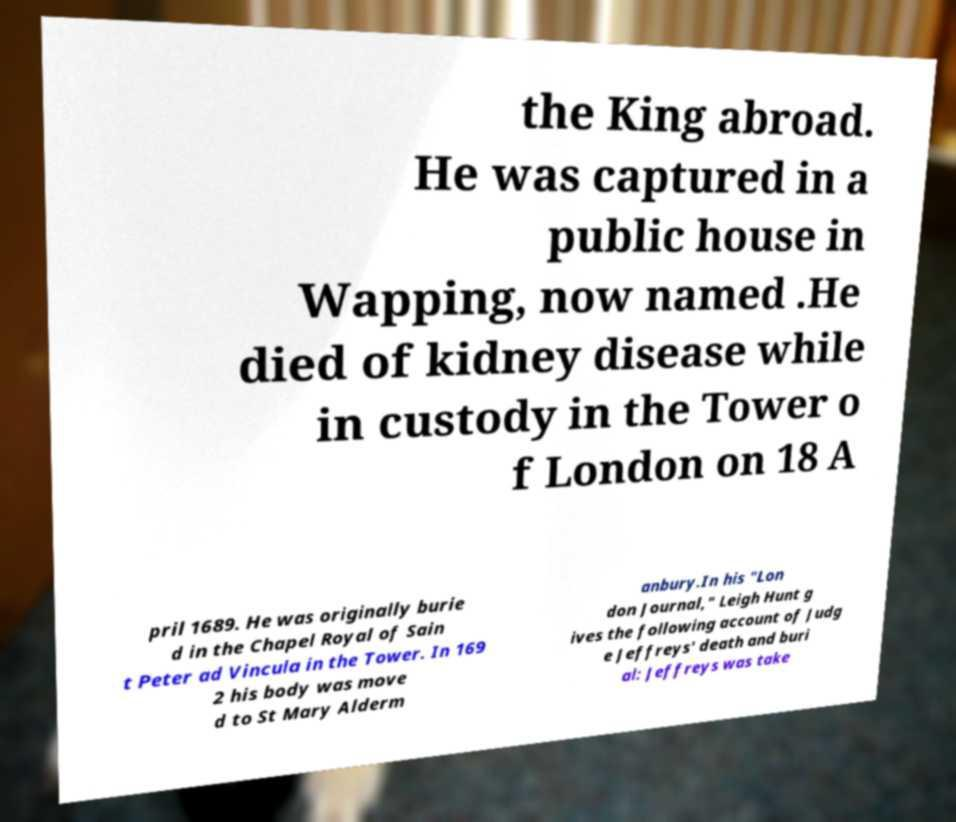Could you extract and type out the text from this image? the King abroad. He was captured in a public house in Wapping, now named .He died of kidney disease while in custody in the Tower o f London on 18 A pril 1689. He was originally burie d in the Chapel Royal of Sain t Peter ad Vincula in the Tower. In 169 2 his body was move d to St Mary Alderm anbury.In his "Lon don Journal," Leigh Hunt g ives the following account of Judg e Jeffreys' death and buri al: Jeffreys was take 